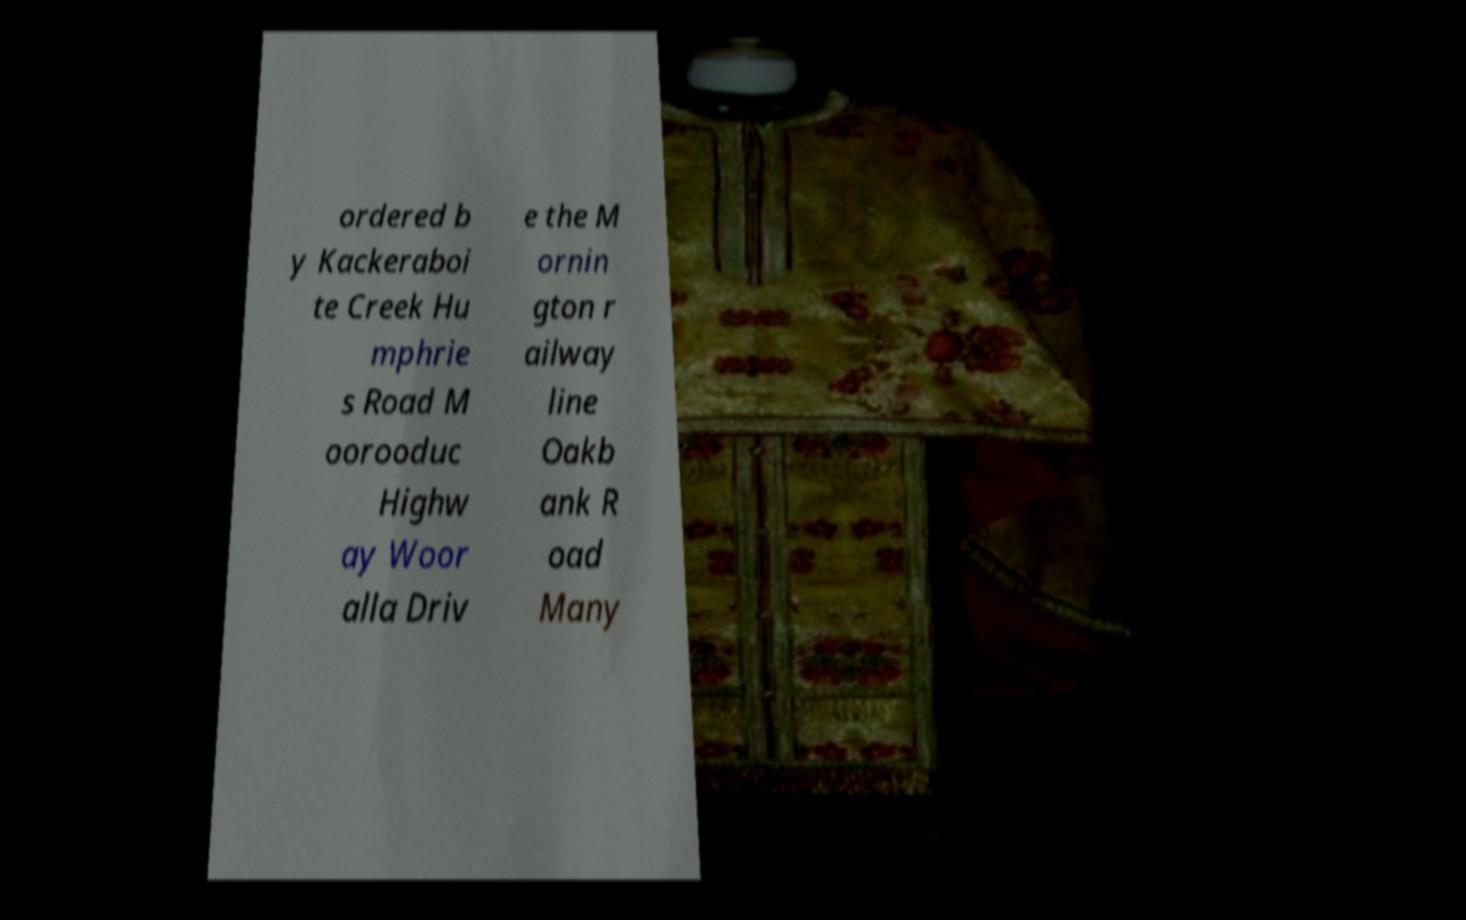Please identify and transcribe the text found in this image. ordered b y Kackeraboi te Creek Hu mphrie s Road M oorooduc Highw ay Woor alla Driv e the M ornin gton r ailway line Oakb ank R oad Many 